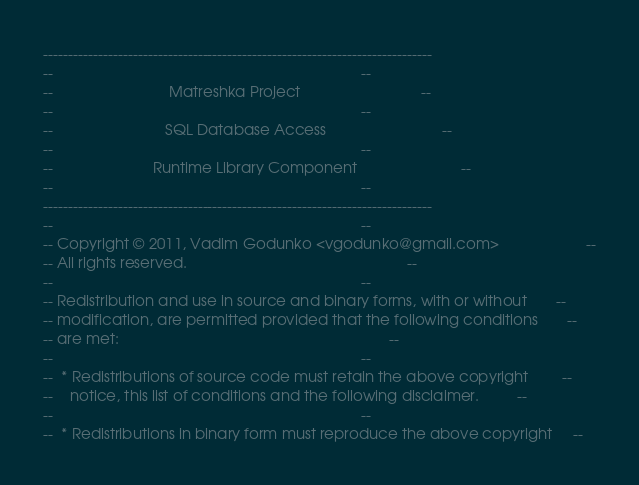Convert code to text. <code><loc_0><loc_0><loc_500><loc_500><_Ada_>------------------------------------------------------------------------------
--                                                                          --
--                            Matreshka Project                             --
--                                                                          --
--                           SQL Database Access                            --
--                                                                          --
--                        Runtime Library Component                         --
--                                                                          --
------------------------------------------------------------------------------
--                                                                          --
-- Copyright © 2011, Vadim Godunko <vgodunko@gmail.com>                     --
-- All rights reserved.                                                     --
--                                                                          --
-- Redistribution and use in source and binary forms, with or without       --
-- modification, are permitted provided that the following conditions       --
-- are met:                                                                 --
--                                                                          --
--  * Redistributions of source code must retain the above copyright        --
--    notice, this list of conditions and the following disclaimer.         --
--                                                                          --
--  * Redistributions in binary form must reproduce the above copyright     --</code> 